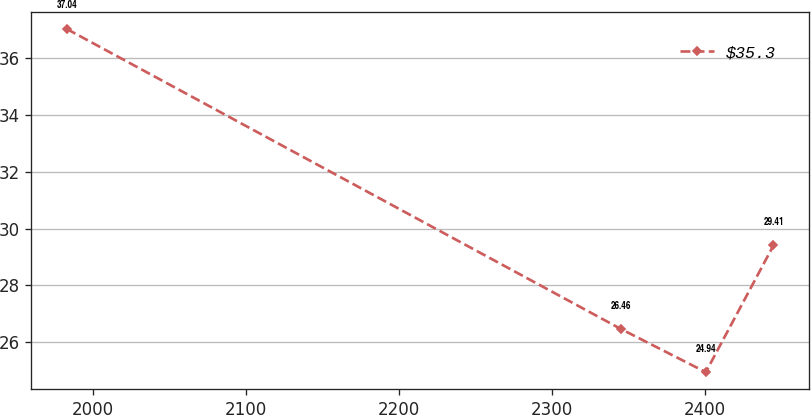Convert chart to OTSL. <chart><loc_0><loc_0><loc_500><loc_500><line_chart><ecel><fcel>$35.3<nl><fcel>1983.07<fcel>37.04<nl><fcel>2345.19<fcel>26.46<nl><fcel>2400.56<fcel>24.94<nl><fcel>2444.77<fcel>29.41<nl></chart> 